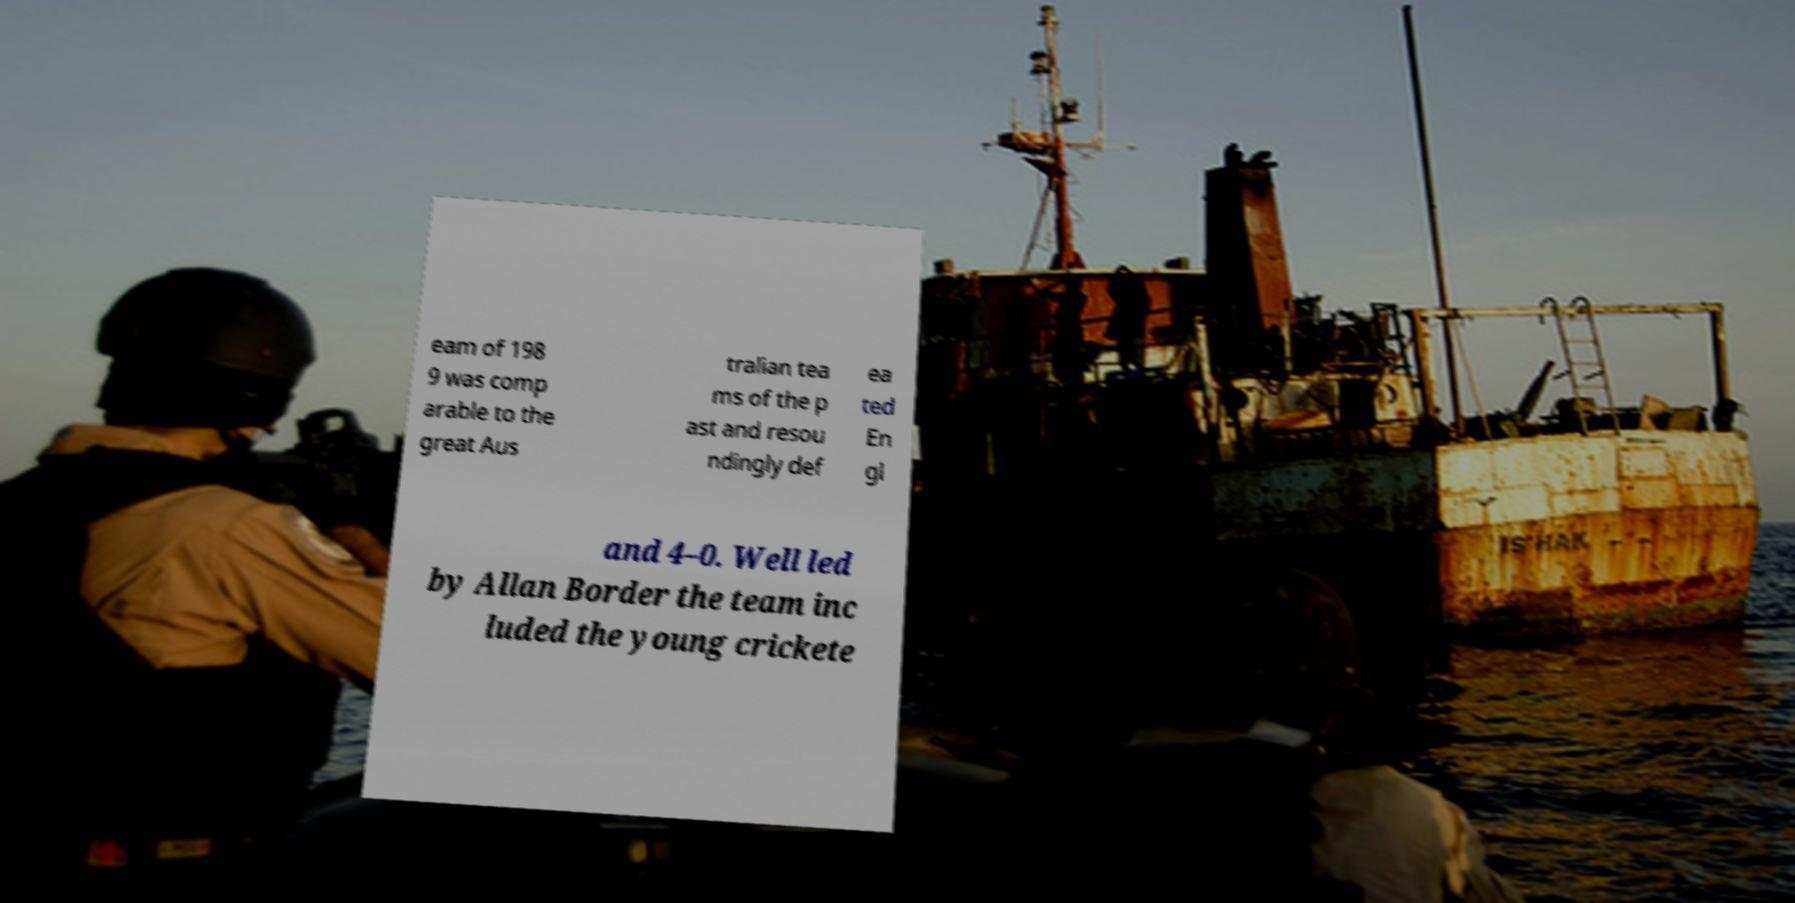I need the written content from this picture converted into text. Can you do that? eam of 198 9 was comp arable to the great Aus tralian tea ms of the p ast and resou ndingly def ea ted En gl and 4–0. Well led by Allan Border the team inc luded the young crickete 